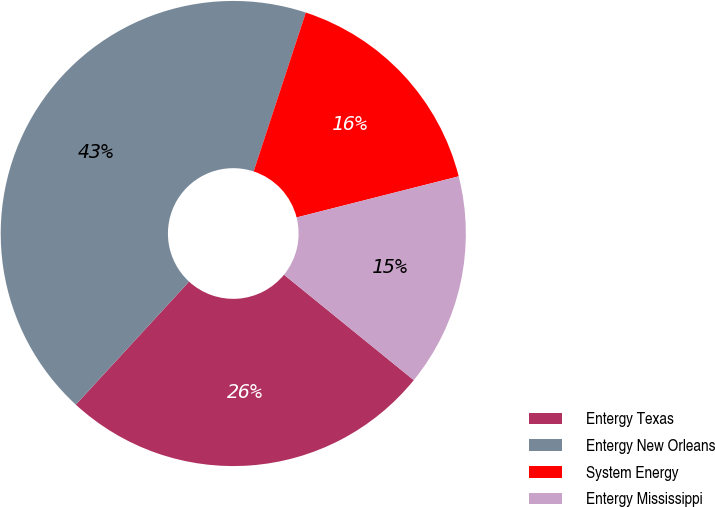Convert chart to OTSL. <chart><loc_0><loc_0><loc_500><loc_500><pie_chart><fcel>Entergy Texas<fcel>Entergy New Orleans<fcel>System Energy<fcel>Entergy Mississippi<nl><fcel>25.98%<fcel>43.21%<fcel>16.0%<fcel>14.81%<nl></chart> 